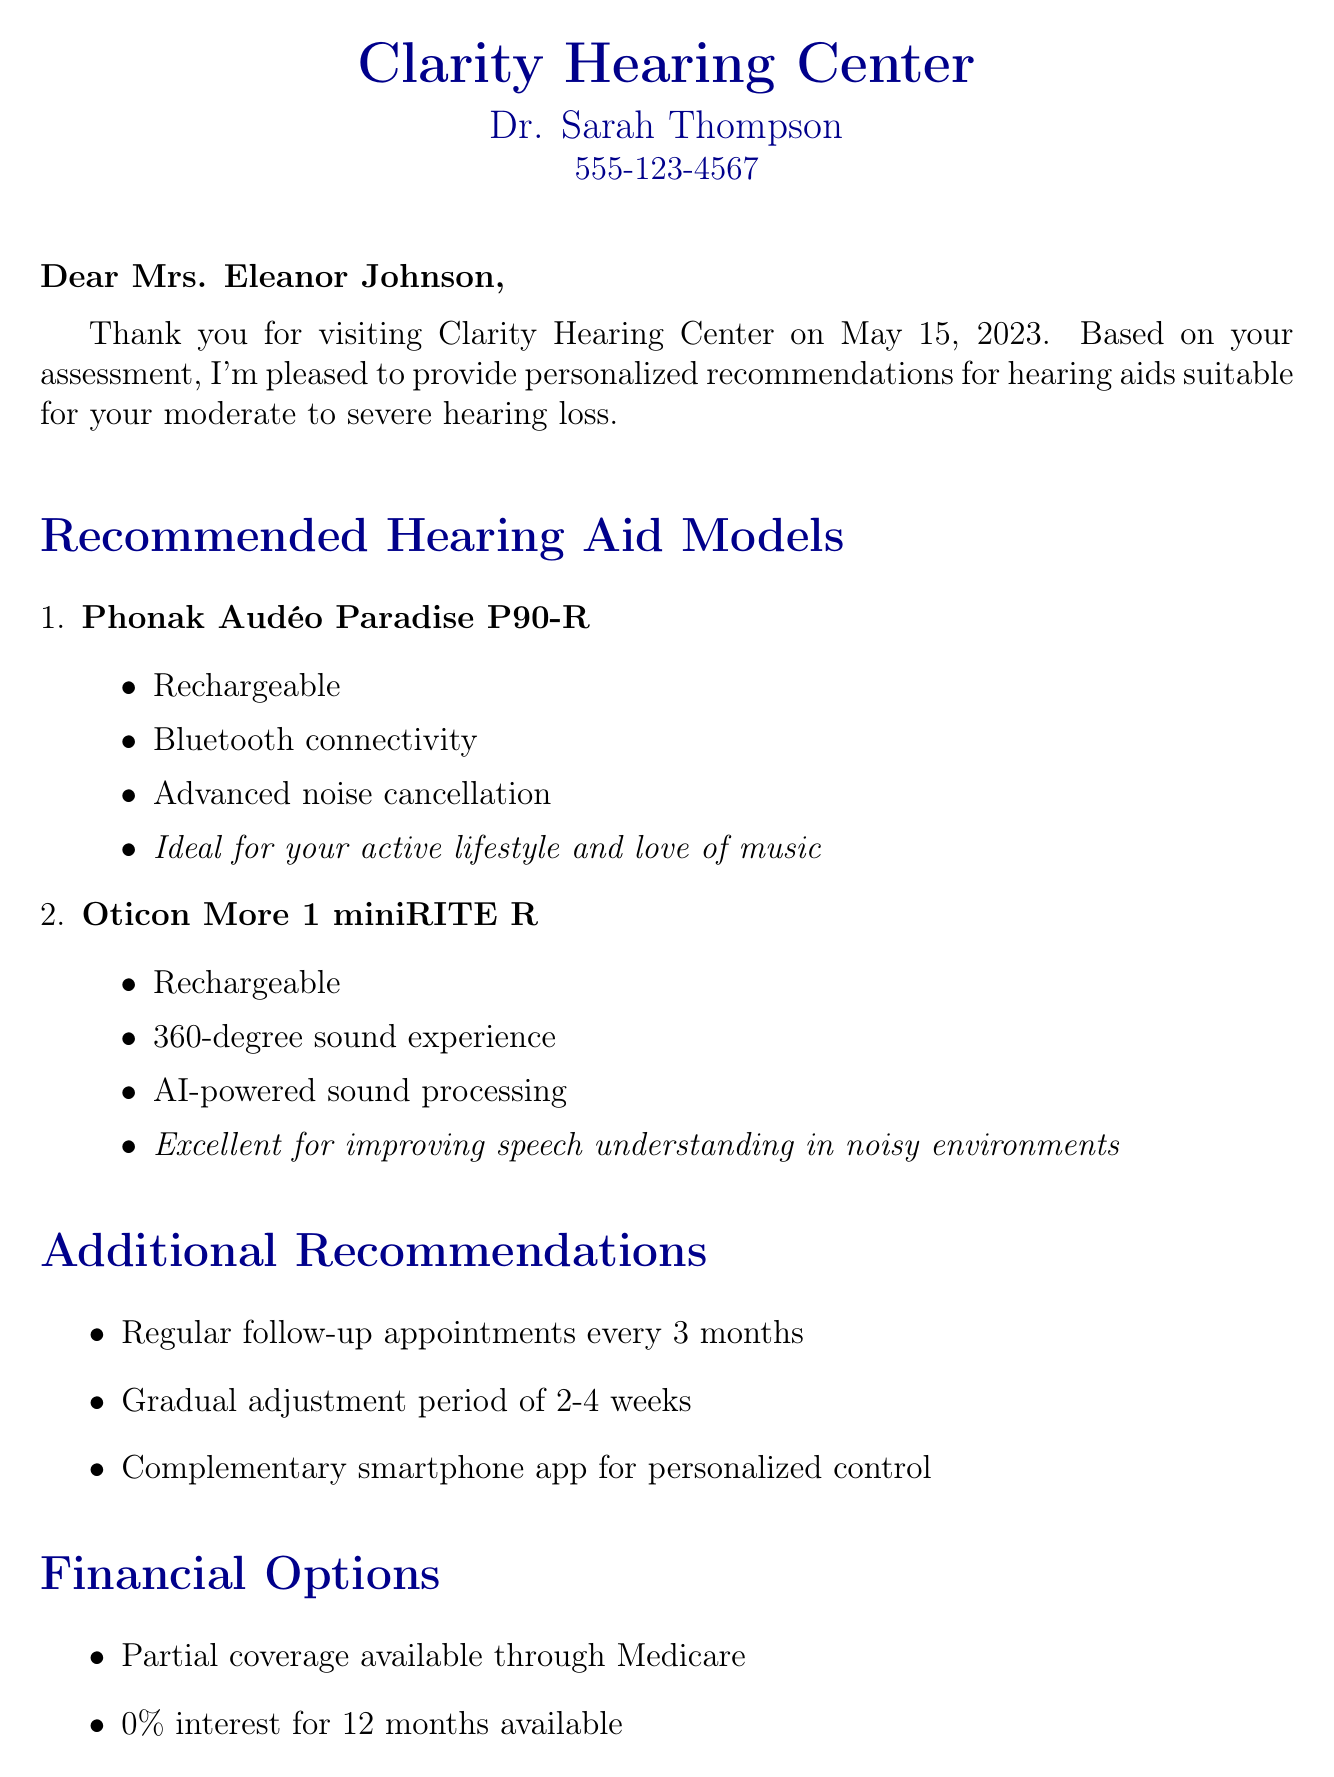What is the name of the audiologist? The document explicitly states the audiologist's name is noted in the header.
Answer: Dr. Sarah Thompson What is the clinic name? The clinic's name is mentioned at the beginning of the document.
Answer: Clarity Hearing Center What is Mrs. Johnson's hearing loss level? The level of hearing loss is specified in the patient information section.
Answer: moderate to severe When was the assessment conducted? The date of the assessment is provided clearly in the document.
Answer: May 15, 2023 What features does the Phonak model have? The document lists features for the recommended models, specifically for Phonak.
Answer: Rechargeable, Bluetooth connectivity, Advanced noise cancellation Which hearing aid is recommended for noisy environments? The suitability section discusses which model excels in noisy conditions.
Answer: Oticon More 1 miniRITE R How often should follow-up appointments be scheduled? The frequency of follow-up appointments is outlined in the recommendations section.
Answer: every 3 months What payment plan is offered? Financial options section mentions specific payment options available.
Answer: 0% interest for 12 months What is the next step after receiving the recommendations? The next steps section outlines actions to be taken after receiving the recommendations.
Answer: Schedule a fitting appointment 